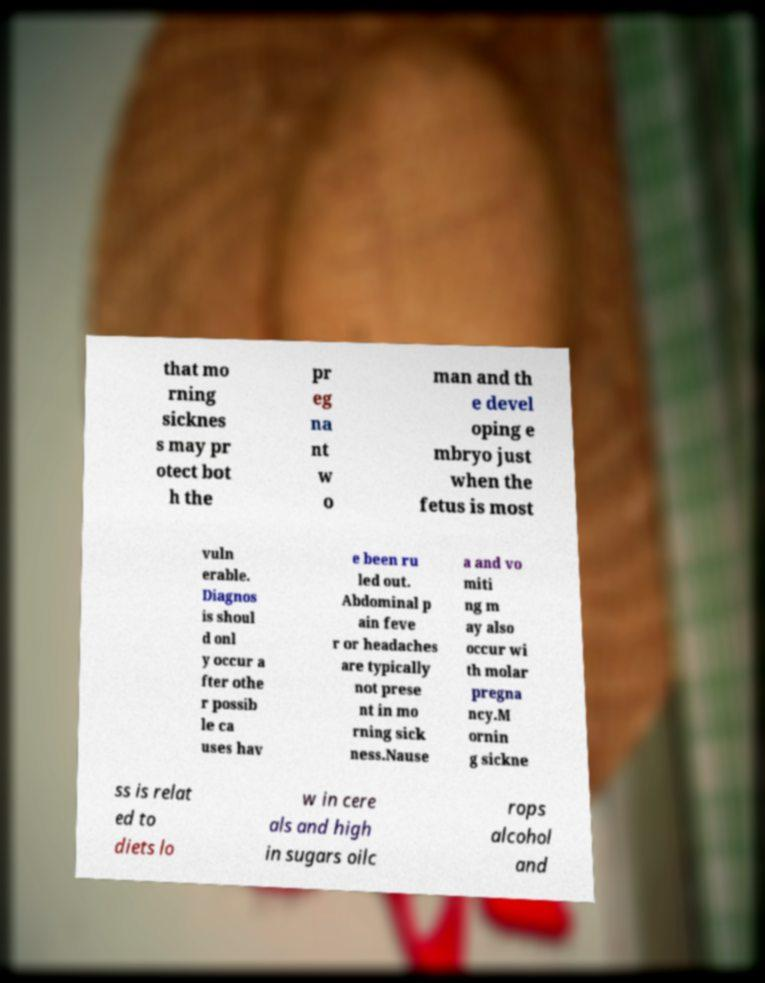I need the written content from this picture converted into text. Can you do that? that mo rning sicknes s may pr otect bot h the pr eg na nt w o man and th e devel oping e mbryo just when the fetus is most vuln erable. Diagnos is shoul d onl y occur a fter othe r possib le ca uses hav e been ru led out. Abdominal p ain feve r or headaches are typically not prese nt in mo rning sick ness.Nause a and vo miti ng m ay also occur wi th molar pregna ncy.M ornin g sickne ss is relat ed to diets lo w in cere als and high in sugars oilc rops alcohol and 